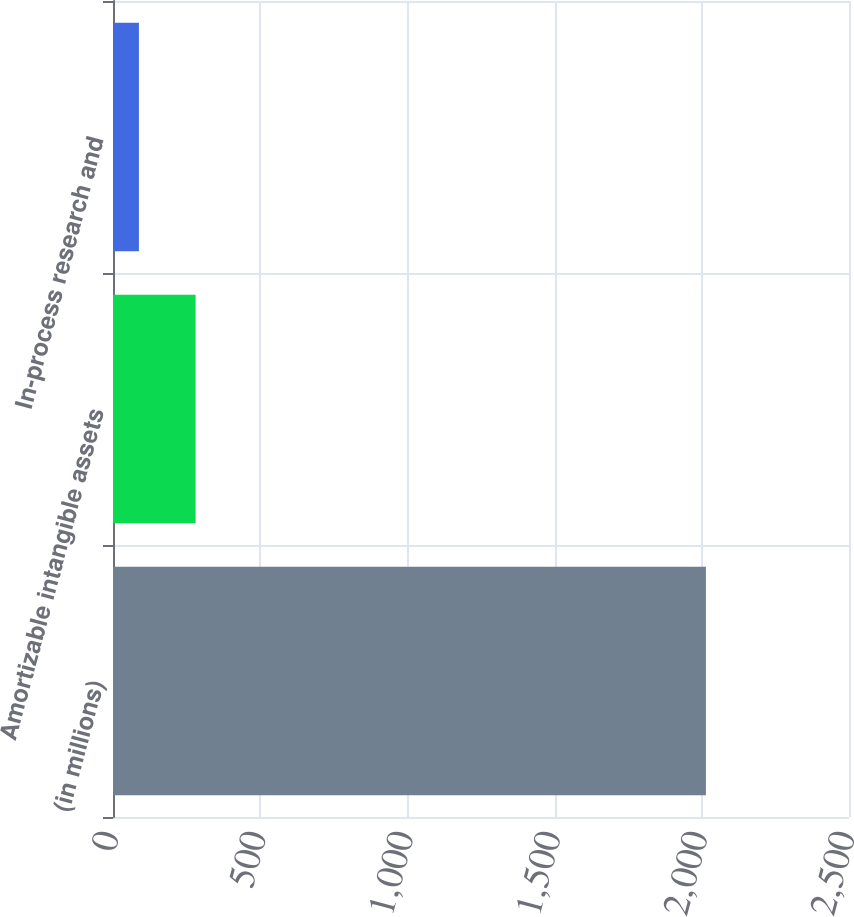Convert chart. <chart><loc_0><loc_0><loc_500><loc_500><bar_chart><fcel>(in millions)<fcel>Amortizable intangible assets<fcel>In-process research and<nl><fcel>2014<fcel>280.6<fcel>88<nl></chart> 